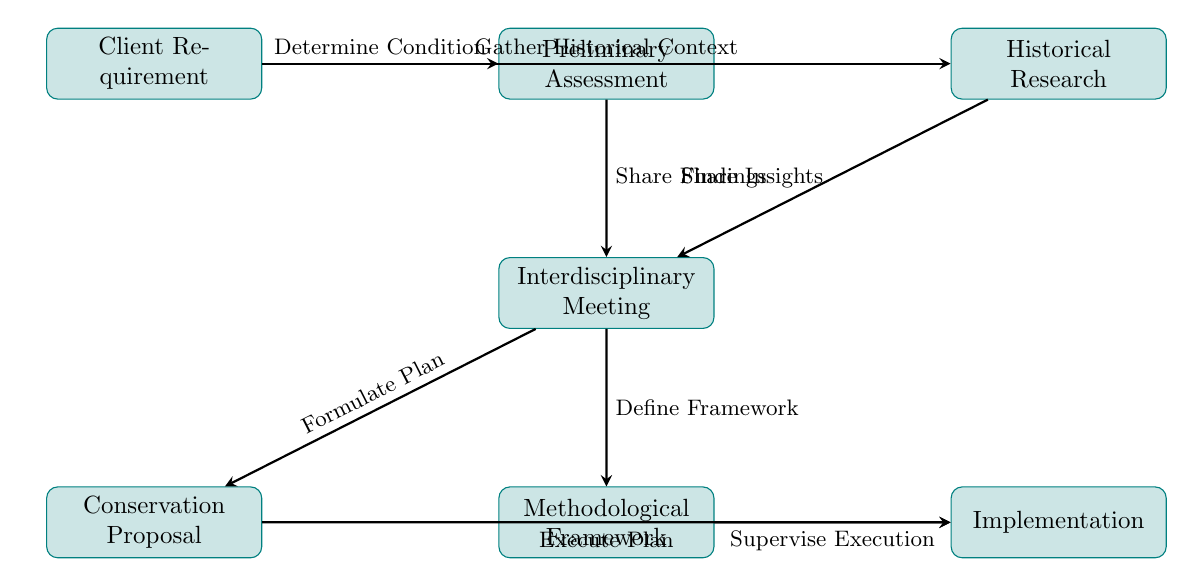What is the first step in the collaboration workflow? The first step is represented by the node labeled "Client Requirement," which denotes the initial understanding of the client’s needs.
Answer: Client Requirement How many nodes are in the diagram? By counting the nodes listed, there are a total of seven nodes in the collaboration workflow diagram.
Answer: 7 What does the arrow from "Preliminary Assessment" to "Interdisciplinary Meeting" signify? This arrow indicates that findings from the preliminary assessment conducted by conservators are shared in the interdisciplinary meeting.
Answer: Share Findings Which two nodes are interconnected by the label "Formulate Plan"? The label "Formulate Plan" connects the nodes "Interdisciplinary Meeting" and "Conservation Proposal," signifying the transition from discussion to planning based on the meeting’s outcomes.
Answer: Interdisciplinary Meeting, Conservation Proposal What is the last step in the workflow? The last step is depicted by the node labeled "Implementation," which represents the execution of the conservation treatment following planning and framework establishment.
Answer: Implementation What role do art historians play in this workflow? Art historians are primarily involved in conducting historical and provenance research as indicated by the node labeled "Historical Research," which then connects to the discussion and planning stages.
Answer: Historical Research Explain the relationship between "Conservation Proposal" and "Implementation." The "Conservation Proposal" node connects to the "Implementation" node, indicating that the conservation treatment is executed based on the developed plan. This connection shows the transition from planning to actual action.
Answer: Execute Plan What connects "Historical Research" and "Interdisciplinary Meeting"? The connection is labeled "Share Insights," indicating that insights from the historical research conducted by art historians are also shared during the interdisciplinary meeting.
Answer: Share Insights Which two nodes involve the establishment of frameworks or proposals? The two nodes that involve establishing frameworks or proposals are "Conservation Proposal" and "Methodological Framework," both resulting from discussions in the "Interdisciplinary Meeting."
Answer: Conservation Proposal, Methodological Framework 